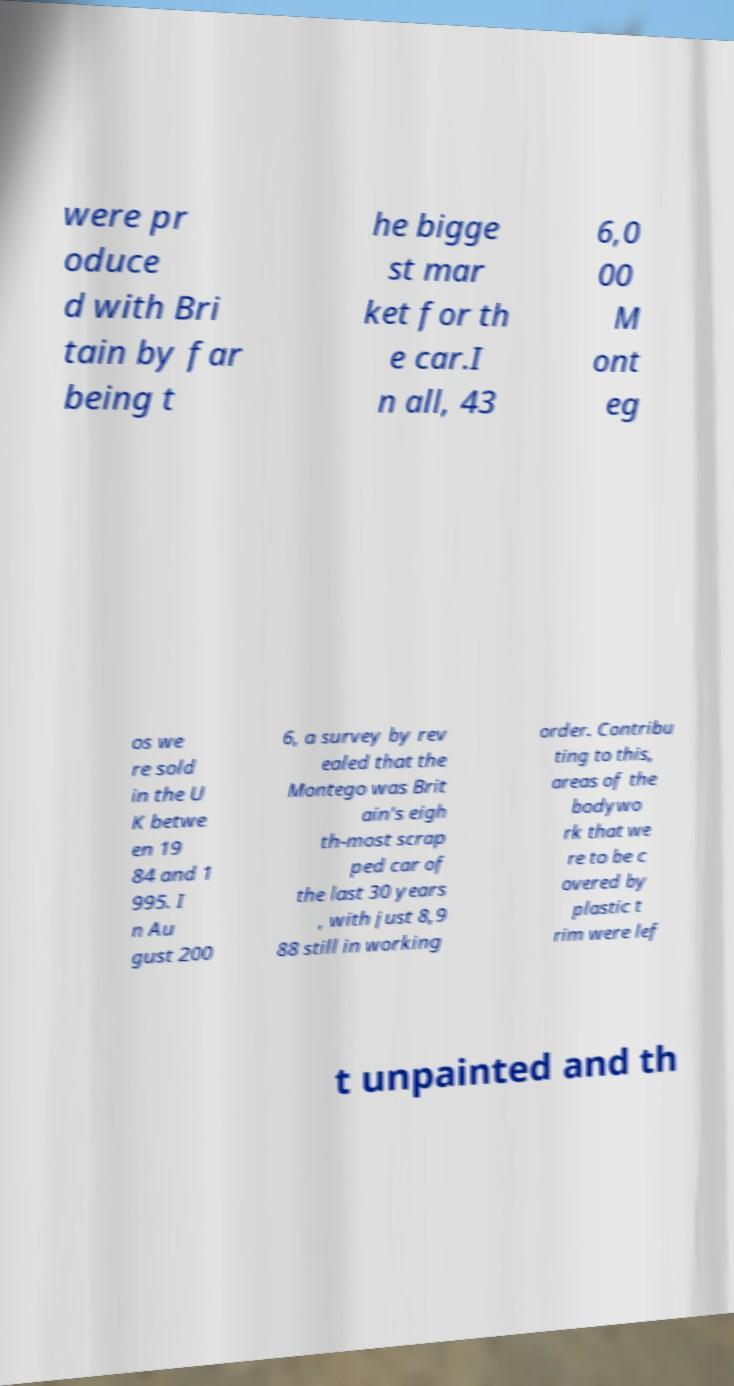I need the written content from this picture converted into text. Can you do that? were pr oduce d with Bri tain by far being t he bigge st mar ket for th e car.I n all, 43 6,0 00 M ont eg os we re sold in the U K betwe en 19 84 and 1 995. I n Au gust 200 6, a survey by rev ealed that the Montego was Brit ain's eigh th-most scrap ped car of the last 30 years , with just 8,9 88 still in working order. Contribu ting to this, areas of the bodywo rk that we re to be c overed by plastic t rim were lef t unpainted and th 